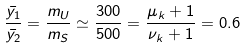<formula> <loc_0><loc_0><loc_500><loc_500>\frac { \bar { y _ { 1 } } } { \bar { y _ { 2 } } } = \frac { m _ { U } } { m _ { S } } \simeq \frac { 3 0 0 } { 5 0 0 } = \frac { \mu _ { k } + 1 } { \nu _ { k } + 1 } = 0 . 6</formula> 